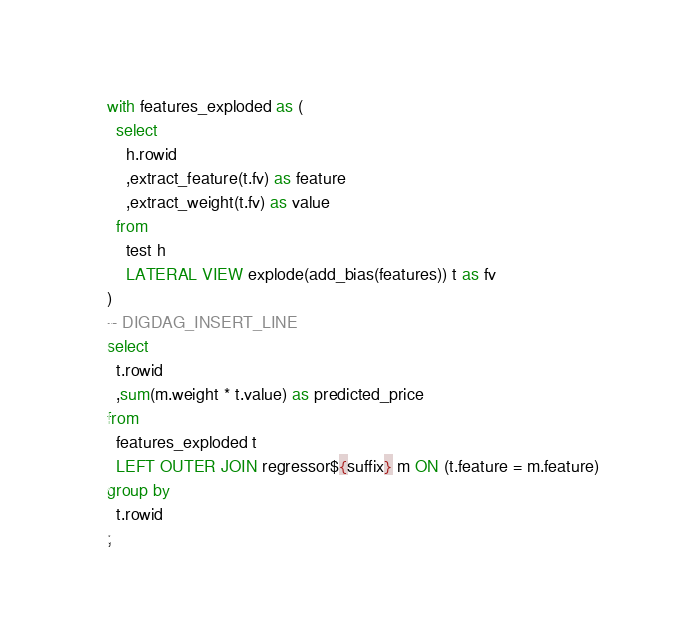Convert code to text. <code><loc_0><loc_0><loc_500><loc_500><_SQL_>with features_exploded as (
  select
    h.rowid
    ,extract_feature(t.fv) as feature
    ,extract_weight(t.fv) as value
  from
    test h
    LATERAL VIEW explode(add_bias(features)) t as fv
)
-- DIGDAG_INSERT_LINE
select
  t.rowid
  ,sum(m.weight * t.value) as predicted_price
from
  features_exploded t
  LEFT OUTER JOIN regressor${suffix} m ON (t.feature = m.feature)
group by
  t.rowid
;
</code> 